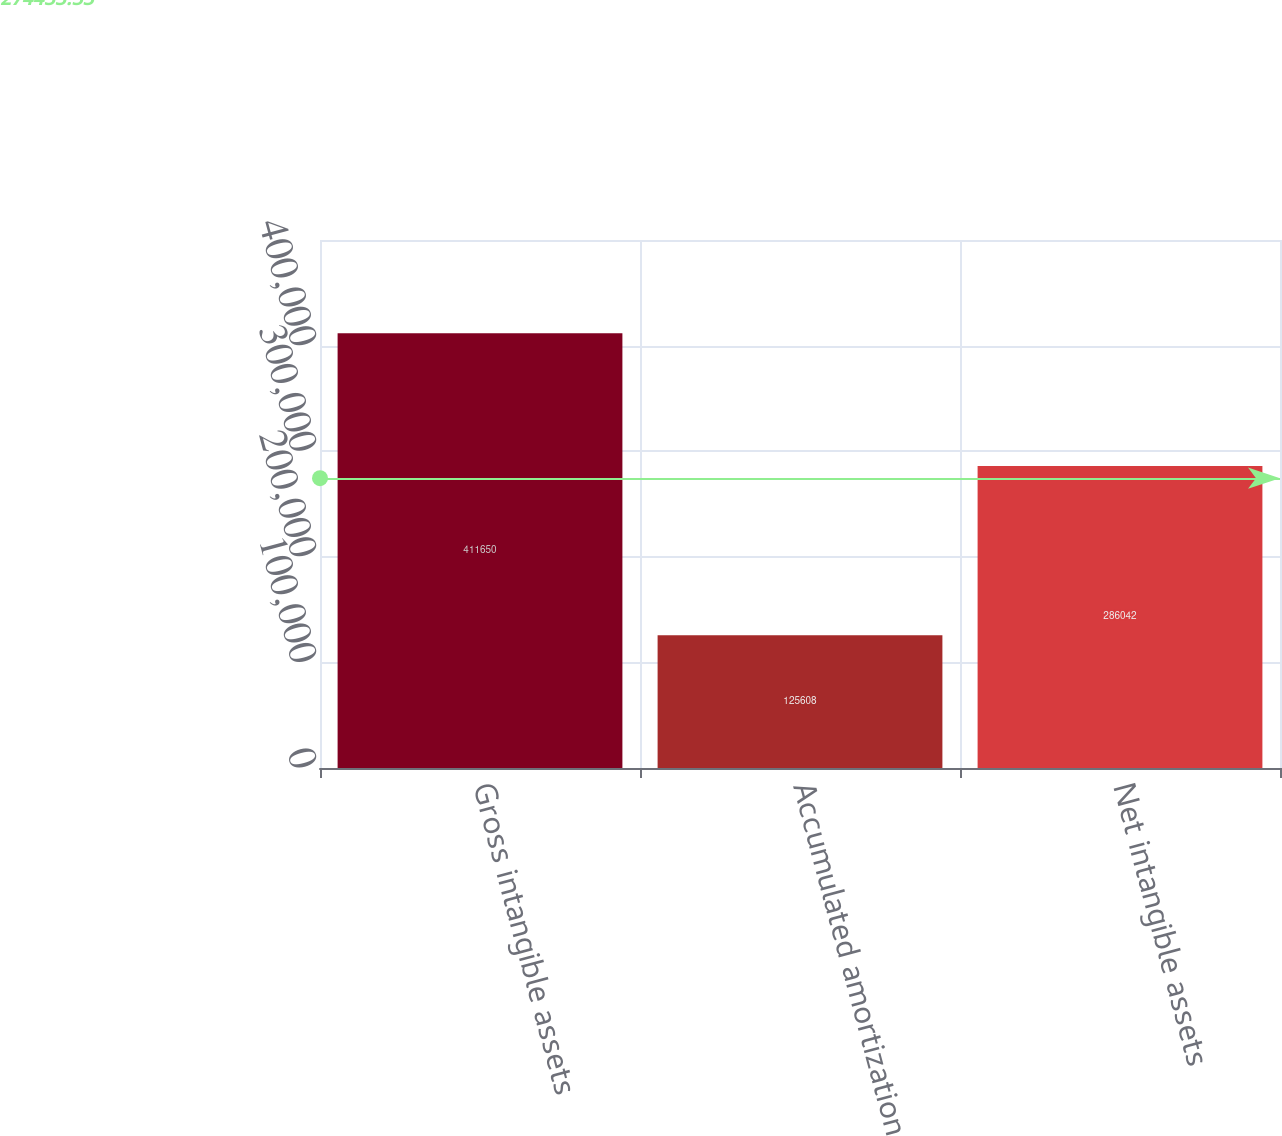<chart> <loc_0><loc_0><loc_500><loc_500><bar_chart><fcel>Gross intangible assets<fcel>Accumulated amortization<fcel>Net intangible assets<nl><fcel>411650<fcel>125608<fcel>286042<nl></chart> 